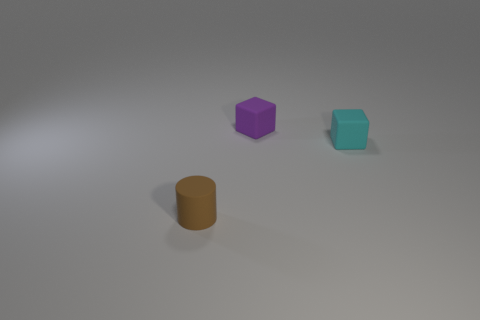There is a cube that is behind the small cyan object; is there a tiny rubber cube behind it?
Your answer should be very brief. No. What number of other objects are there of the same color as the small cylinder?
Make the answer very short. 0. Do the block that is behind the cyan cube and the matte object left of the tiny purple matte block have the same size?
Ensure brevity in your answer.  Yes. How big is the rubber cube to the left of the small block that is right of the purple rubber thing?
Offer a very short reply. Small. What material is the thing that is both in front of the tiny purple thing and on the right side of the cylinder?
Keep it short and to the point. Rubber. What is the color of the cylinder?
Your answer should be compact. Brown. Is there anything else that has the same material as the purple cube?
Your response must be concise. Yes. There is a small thing that is left of the small purple cube; what is its shape?
Your response must be concise. Cylinder. Is there a tiny brown rubber cylinder that is behind the cube on the right side of the block that is to the left of the cyan block?
Your answer should be compact. No. Are there any other things that are the same shape as the tiny purple object?
Keep it short and to the point. Yes. 